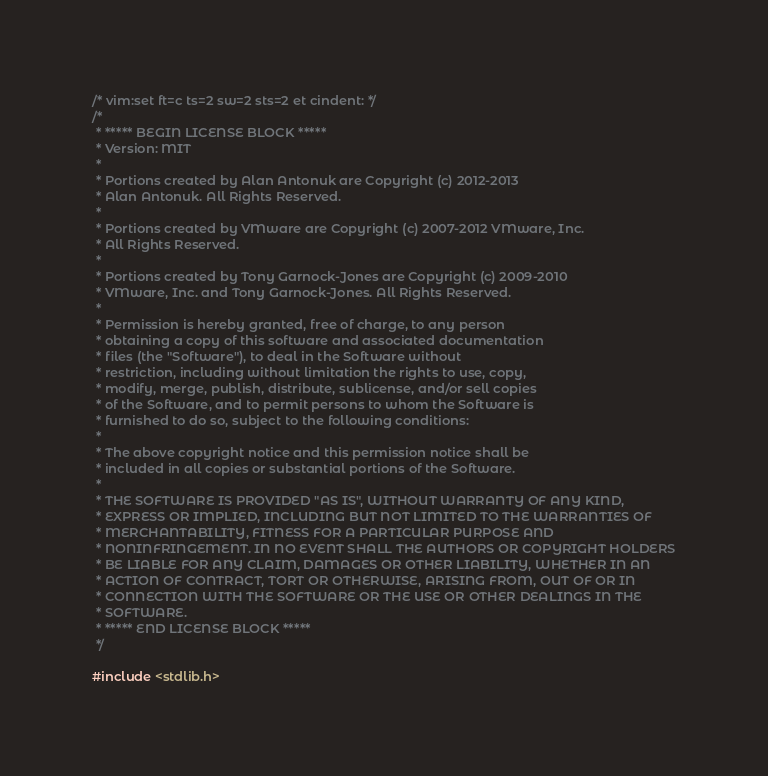Convert code to text. <code><loc_0><loc_0><loc_500><loc_500><_C_>/* vim:set ft=c ts=2 sw=2 sts=2 et cindent: */
/*
 * ***** BEGIN LICENSE BLOCK *****
 * Version: MIT
 *
 * Portions created by Alan Antonuk are Copyright (c) 2012-2013
 * Alan Antonuk. All Rights Reserved.
 *
 * Portions created by VMware are Copyright (c) 2007-2012 VMware, Inc.
 * All Rights Reserved.
 *
 * Portions created by Tony Garnock-Jones are Copyright (c) 2009-2010
 * VMware, Inc. and Tony Garnock-Jones. All Rights Reserved.
 *
 * Permission is hereby granted, free of charge, to any person
 * obtaining a copy of this software and associated documentation
 * files (the "Software"), to deal in the Software without
 * restriction, including without limitation the rights to use, copy,
 * modify, merge, publish, distribute, sublicense, and/or sell copies
 * of the Software, and to permit persons to whom the Software is
 * furnished to do so, subject to the following conditions:
 *
 * The above copyright notice and this permission notice shall be
 * included in all copies or substantial portions of the Software.
 *
 * THE SOFTWARE IS PROVIDED "AS IS", WITHOUT WARRANTY OF ANY KIND,
 * EXPRESS OR IMPLIED, INCLUDING BUT NOT LIMITED TO THE WARRANTIES OF
 * MERCHANTABILITY, FITNESS FOR A PARTICULAR PURPOSE AND
 * NONINFRINGEMENT. IN NO EVENT SHALL THE AUTHORS OR COPYRIGHT HOLDERS
 * BE LIABLE FOR ANY CLAIM, DAMAGES OR OTHER LIABILITY, WHETHER IN AN
 * ACTION OF CONTRACT, TORT OR OTHERWISE, ARISING FROM, OUT OF OR IN
 * CONNECTION WITH THE SOFTWARE OR THE USE OR OTHER DEALINGS IN THE
 * SOFTWARE.
 * ***** END LICENSE BLOCK *****
 */

#include <stdlib.h></code> 